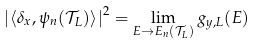Convert formula to latex. <formula><loc_0><loc_0><loc_500><loc_500>\left | \left \langle \delta _ { x } , \psi _ { n } ( \mathcal { T } _ { L } ) \right \rangle \right | ^ { 2 } = \lim _ { E \to E _ { n } ( \mathcal { T } _ { L } ) } g _ { y , L } ( E )</formula> 